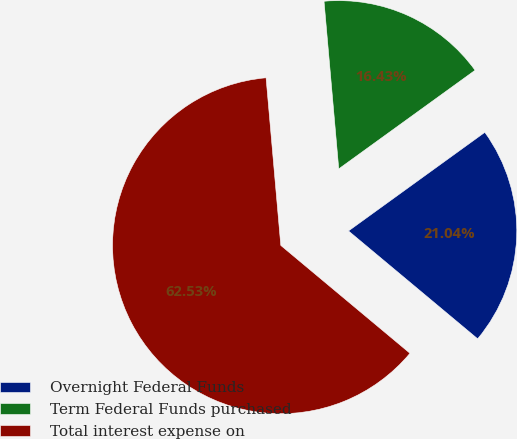Convert chart to OTSL. <chart><loc_0><loc_0><loc_500><loc_500><pie_chart><fcel>Overnight Federal Funds<fcel>Term Federal Funds purchased<fcel>Total interest expense on<nl><fcel>21.04%<fcel>16.43%<fcel>62.53%<nl></chart> 